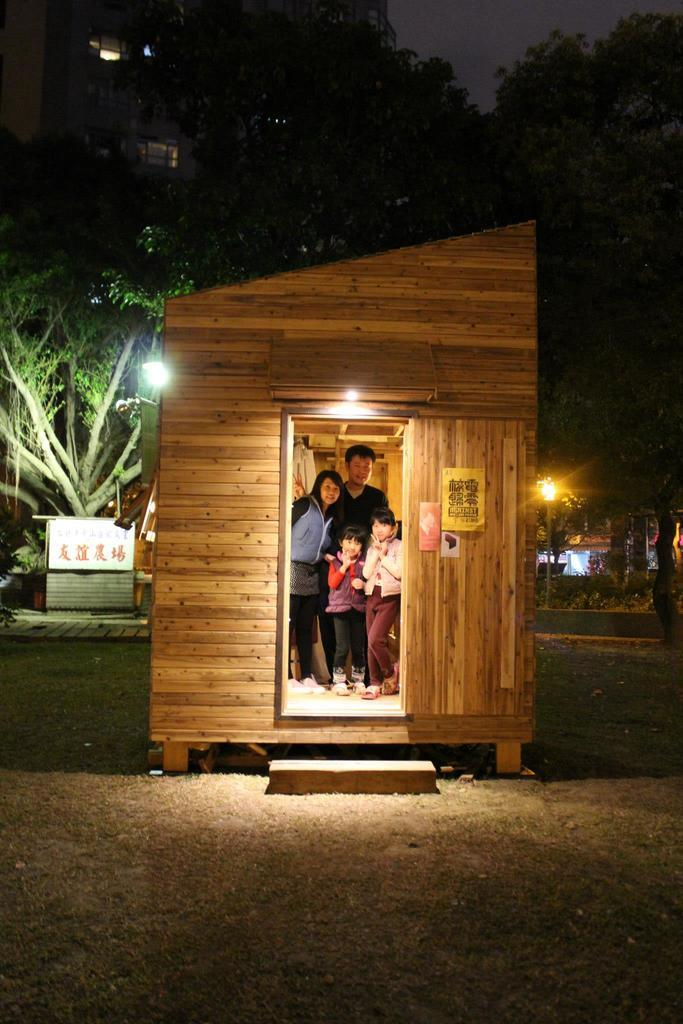How many people are in the wooden house in the image? There are four persons standing in a wooden house in the image. What can be seen in the image besides the people and the wooden house? There are lights and trees in the background of the image. What is visible at the top of the image? The sky is visible at the top of the image. What type of drum is being played in the image? There is no drum present in the image. What account number is associated with the wooden house in the image? There is no mention of an account number or any financial information in the image. 